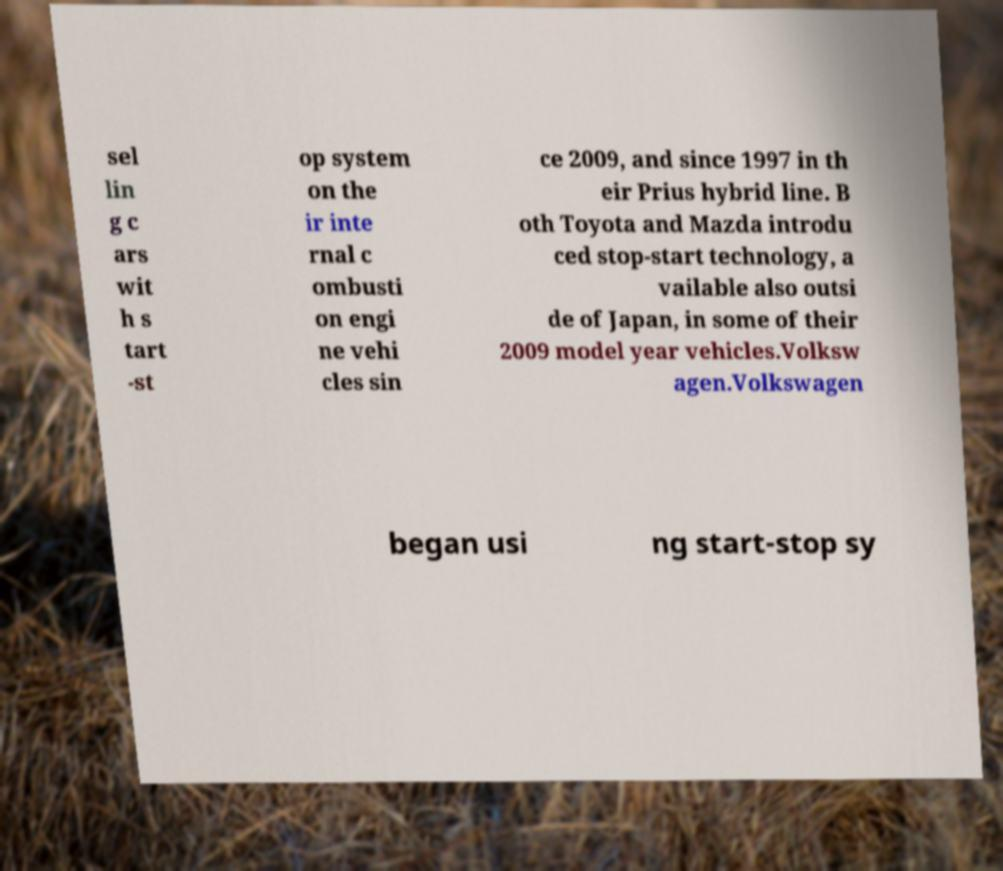Please read and relay the text visible in this image. What does it say? sel lin g c ars wit h s tart -st op system on the ir inte rnal c ombusti on engi ne vehi cles sin ce 2009, and since 1997 in th eir Prius hybrid line. B oth Toyota and Mazda introdu ced stop-start technology, a vailable also outsi de of Japan, in some of their 2009 model year vehicles.Volksw agen.Volkswagen began usi ng start-stop sy 